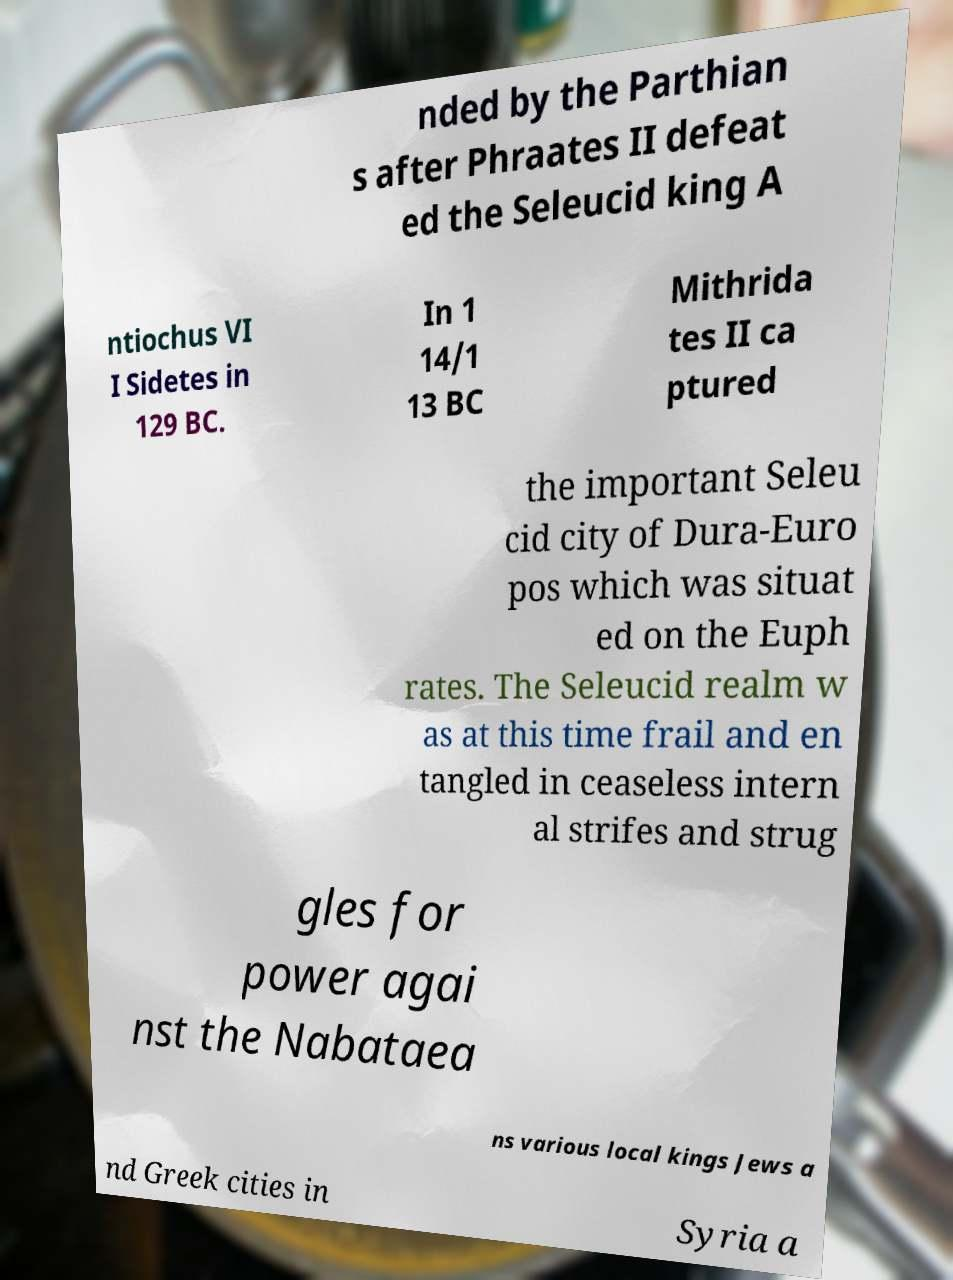There's text embedded in this image that I need extracted. Can you transcribe it verbatim? nded by the Parthian s after Phraates II defeat ed the Seleucid king A ntiochus VI I Sidetes in 129 BC. In 1 14/1 13 BC Mithrida tes II ca ptured the important Seleu cid city of Dura-Euro pos which was situat ed on the Euph rates. The Seleucid realm w as at this time frail and en tangled in ceaseless intern al strifes and strug gles for power agai nst the Nabataea ns various local kings Jews a nd Greek cities in Syria a 